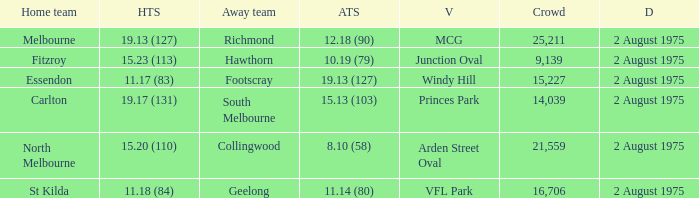How many people attended the game at VFL Park? 16706.0. 